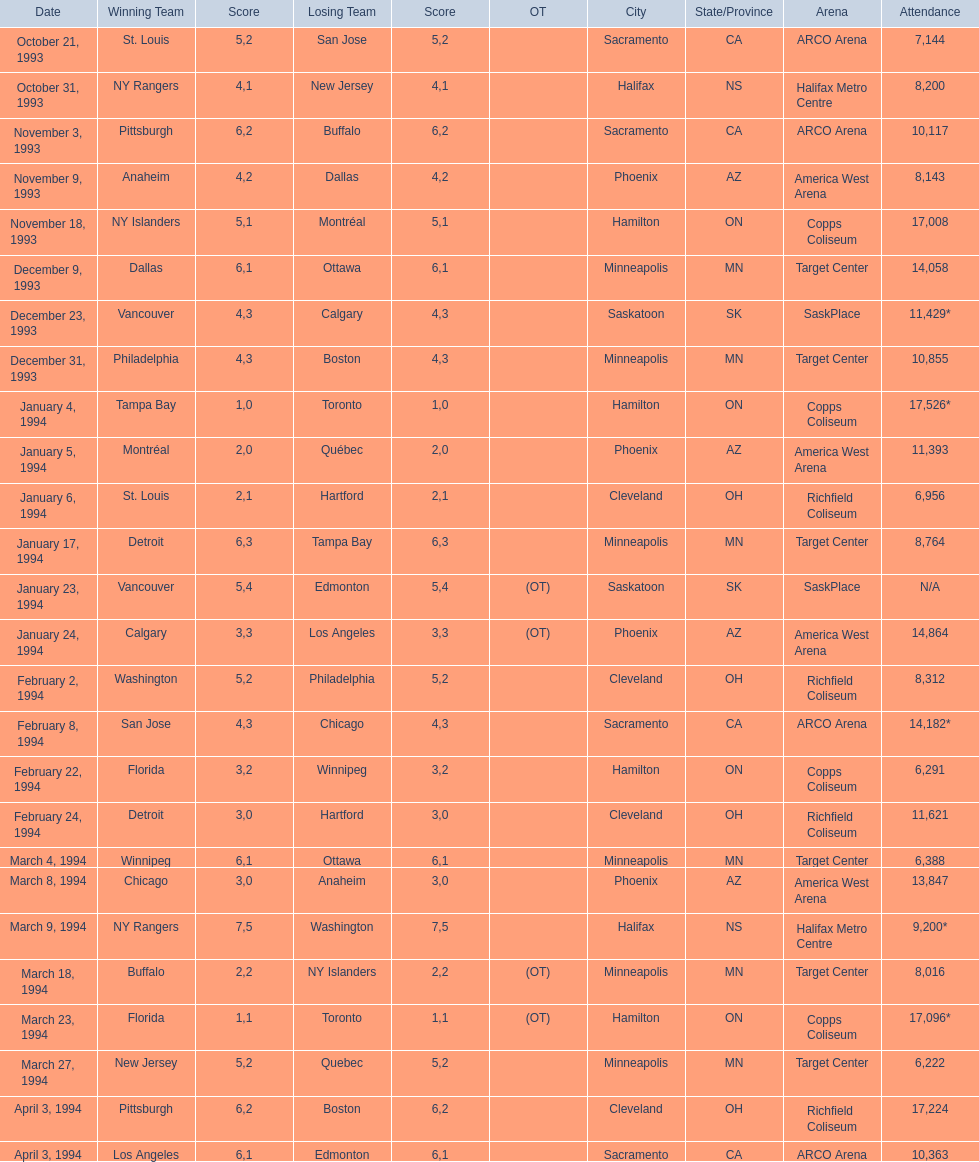Between january 24, 1994, and december 23, 1993, which event had a larger number of attendees? January 4, 1994. 